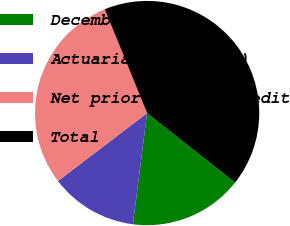<chart> <loc_0><loc_0><loc_500><loc_500><pie_chart><fcel>December 31<fcel>Actuarial net (loss)<fcel>Net prior service credit<fcel>Total<nl><fcel>16.4%<fcel>12.6%<fcel>29.2%<fcel>41.8%<nl></chart> 